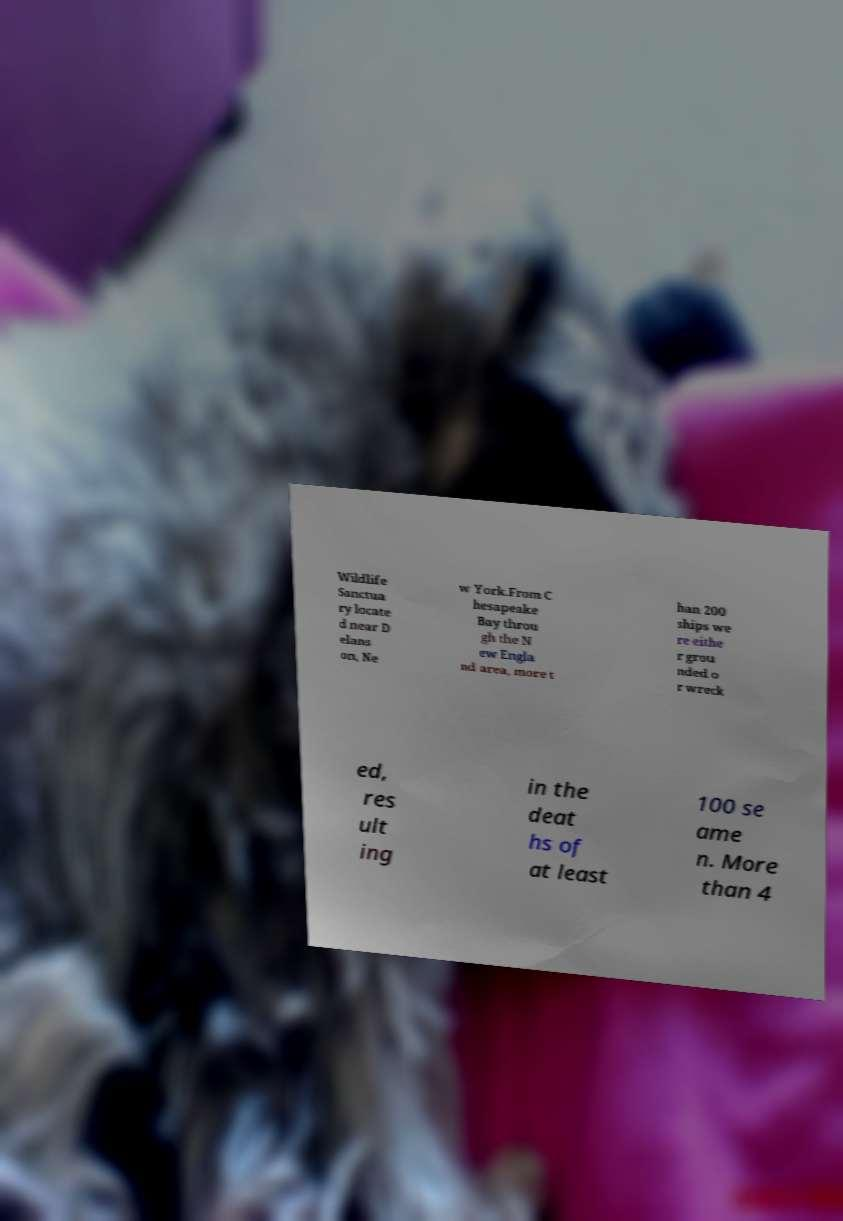Could you assist in decoding the text presented in this image and type it out clearly? Wildlife Sanctua ry locate d near D elans on, Ne w York.From C hesapeake Bay throu gh the N ew Engla nd area, more t han 200 ships we re eithe r grou nded o r wreck ed, res ult ing in the deat hs of at least 100 se ame n. More than 4 